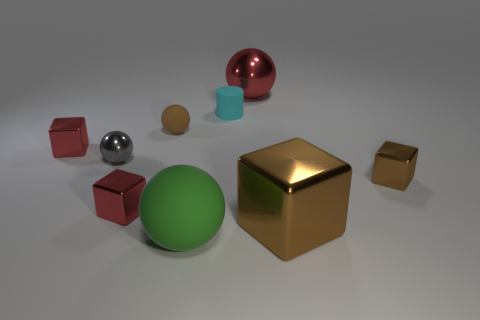Subtract all small blocks. How many blocks are left? 1 Subtract all red cubes. How many cubes are left? 2 Subtract all cylinders. How many objects are left? 8 Subtract 1 spheres. How many spheres are left? 3 Subtract all blue cylinders. Subtract all brown spheres. How many cylinders are left? 1 Subtract all yellow cylinders. How many red cubes are left? 2 Subtract all brown balls. Subtract all small matte spheres. How many objects are left? 7 Add 5 big metal objects. How many big metal objects are left? 7 Add 8 big blocks. How many big blocks exist? 9 Subtract 1 green balls. How many objects are left? 8 